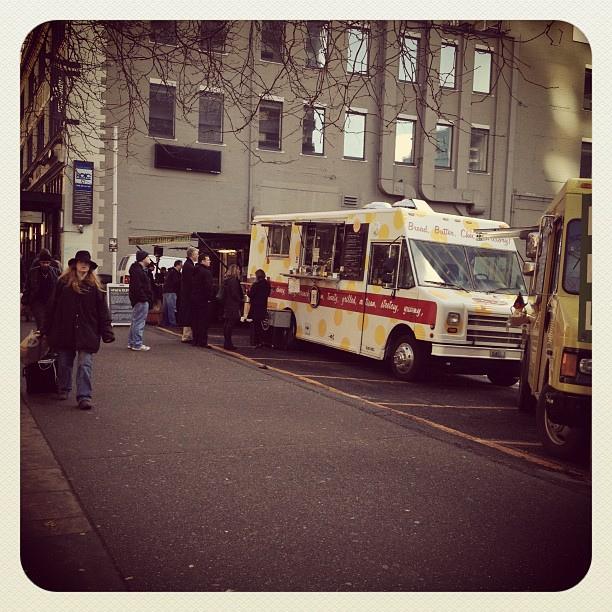How many people are in the photo?
Keep it brief. 9. Is anyone facing the camera?
Write a very short answer. Yes. How many beams are on the ceiling?
Be succinct. 0. What color is the lady's bonnet?
Concise answer only. Black. What color are the lines on the road?
Write a very short answer. Yellow. What kind of mirror is this?
Be succinct. None. How many windows are in this picture?
Answer briefly. 16. Is it summertime?
Be succinct. No. Why are people standing around the truck?
Give a very brief answer. Food. Is this photo clear?
Answer briefly. Yes. Can one get food from this truck?
Write a very short answer. Yes. Does the building have columns?
Quick response, please. No. What type of food is drawn on the side of the bus?
Short answer required. Bread. 